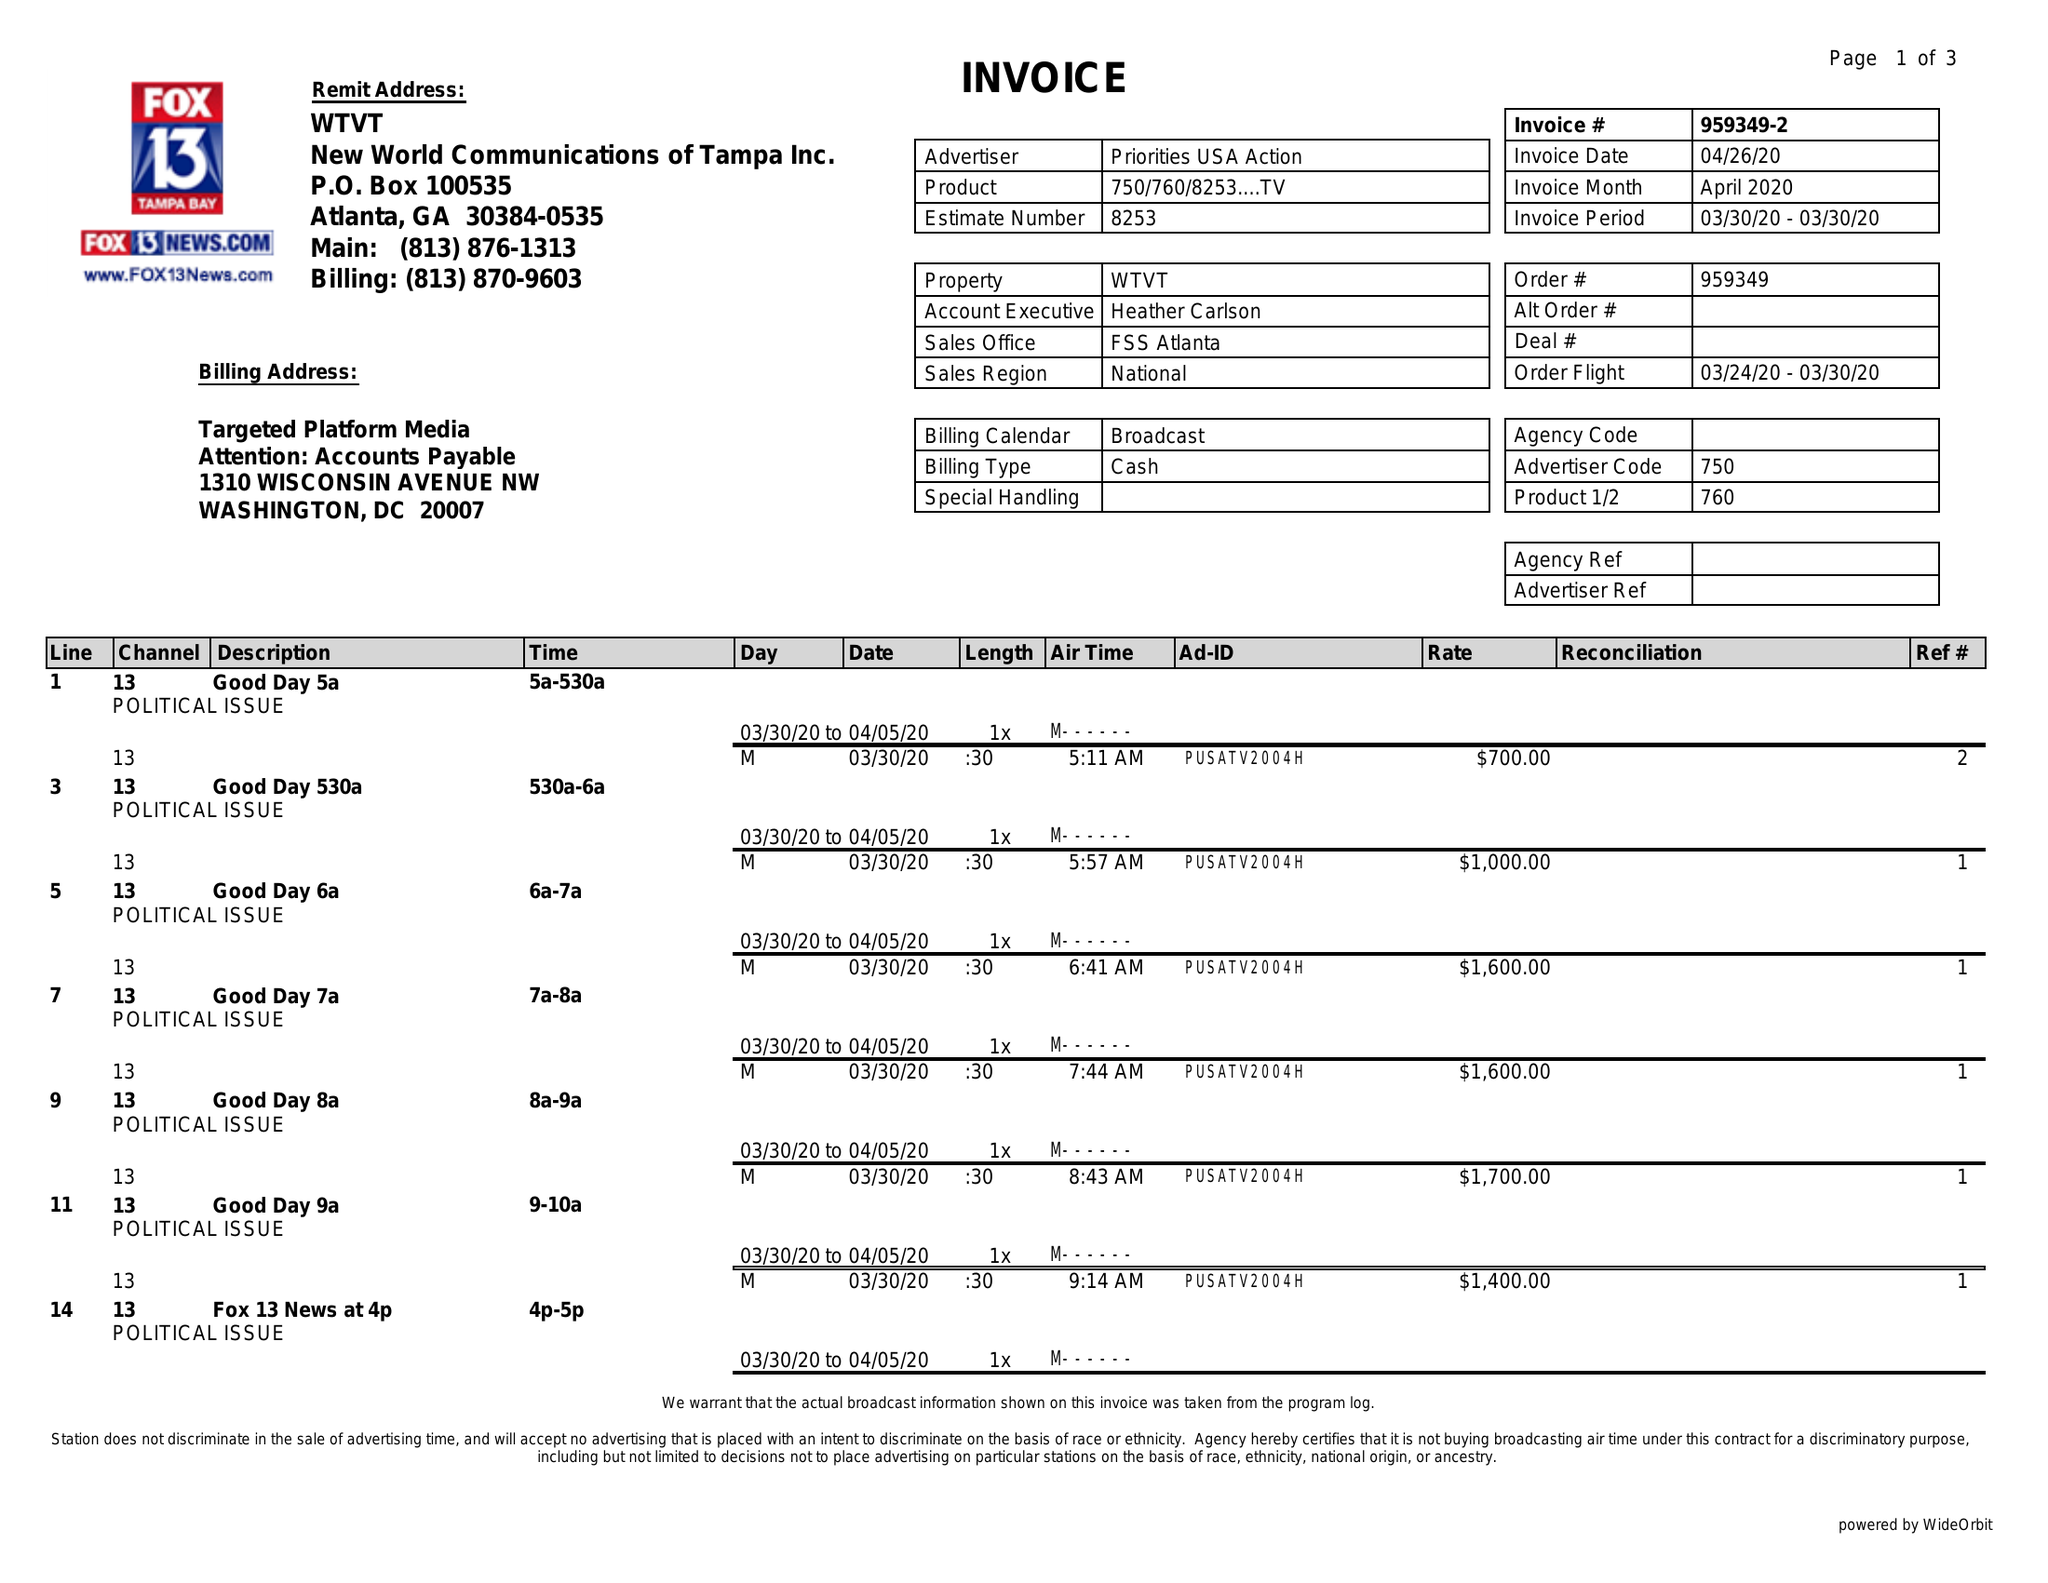What is the value for the advertiser?
Answer the question using a single word or phrase. PRIORITIES USA ACTION 